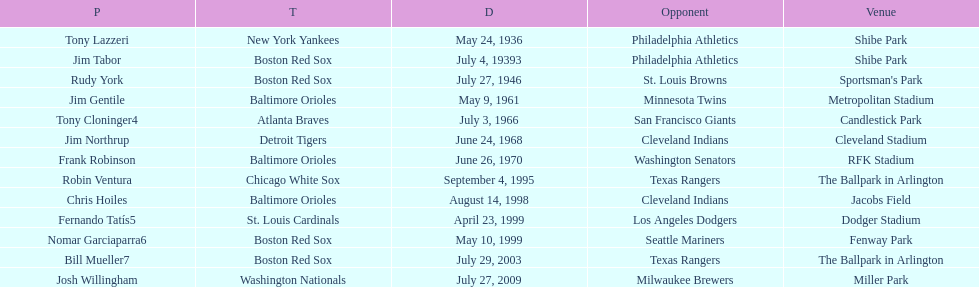I'm looking to parse the entire table for insights. Could you assist me with that? {'header': ['P', 'T', 'D', 'Opponent', 'Venue'], 'rows': [['Tony Lazzeri', 'New York Yankees', 'May 24, 1936', 'Philadelphia Athletics', 'Shibe Park'], ['Jim Tabor', 'Boston Red Sox', 'July 4, 19393', 'Philadelphia Athletics', 'Shibe Park'], ['Rudy York', 'Boston Red Sox', 'July 27, 1946', 'St. Louis Browns', "Sportsman's Park"], ['Jim Gentile', 'Baltimore Orioles', 'May 9, 1961', 'Minnesota Twins', 'Metropolitan Stadium'], ['Tony Cloninger4', 'Atlanta Braves', 'July 3, 1966', 'San Francisco Giants', 'Candlestick Park'], ['Jim Northrup', 'Detroit Tigers', 'June 24, 1968', 'Cleveland Indians', 'Cleveland Stadium'], ['Frank Robinson', 'Baltimore Orioles', 'June 26, 1970', 'Washington Senators', 'RFK Stadium'], ['Robin Ventura', 'Chicago White Sox', 'September 4, 1995', 'Texas Rangers', 'The Ballpark in Arlington'], ['Chris Hoiles', 'Baltimore Orioles', 'August 14, 1998', 'Cleveland Indians', 'Jacobs Field'], ['Fernando Tatís5', 'St. Louis Cardinals', 'April 23, 1999', 'Los Angeles Dodgers', 'Dodger Stadium'], ['Nomar Garciaparra6', 'Boston Red Sox', 'May 10, 1999', 'Seattle Mariners', 'Fenway Park'], ['Bill Mueller7', 'Boston Red Sox', 'July 29, 2003', 'Texas Rangers', 'The Ballpark in Arlington'], ['Josh Willingham', 'Washington Nationals', 'July 27, 2009', 'Milwaukee Brewers', 'Miller Park']]} Who was the opponent for the boston red sox on july 27, 1946? St. Louis Browns. 